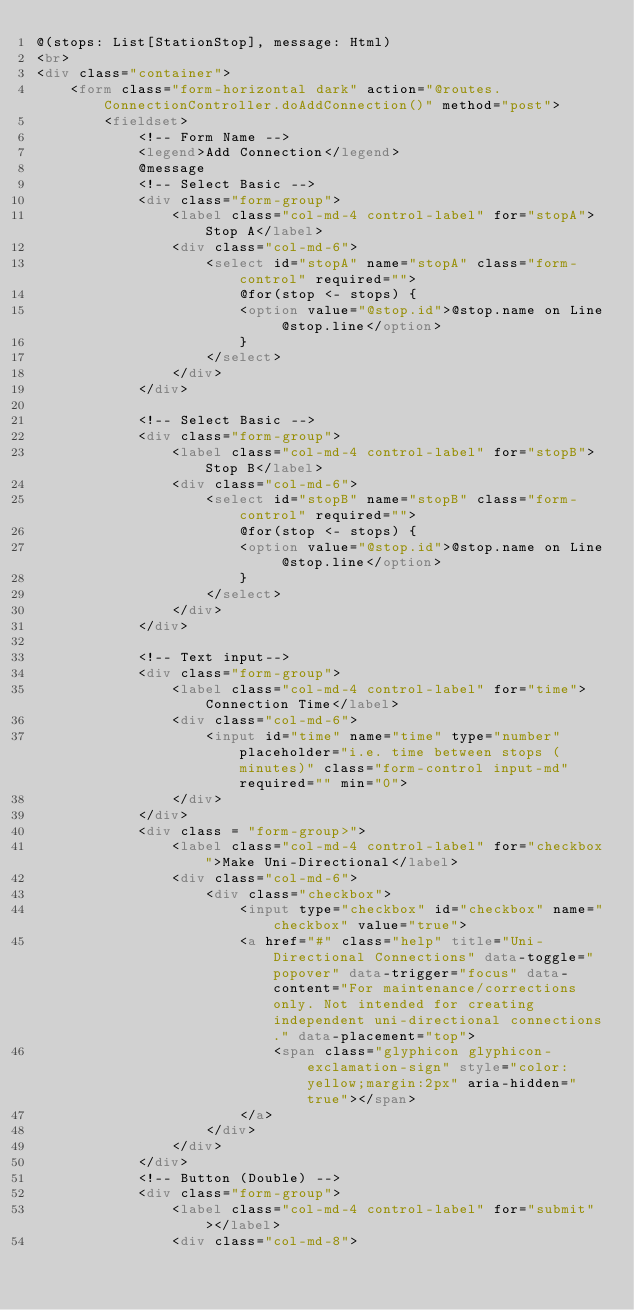Convert code to text. <code><loc_0><loc_0><loc_500><loc_500><_HTML_>@(stops: List[StationStop], message: Html)
<br>
<div class="container">
    <form class="form-horizontal dark" action="@routes.ConnectionController.doAddConnection()" method="post">
        <fieldset>
            <!-- Form Name -->
            <legend>Add Connection</legend>
            @message
            <!-- Select Basic -->
            <div class="form-group">
                <label class="col-md-4 control-label" for="stopA">Stop A</label>
                <div class="col-md-6">
                    <select id="stopA" name="stopA" class="form-control" required="">
                        @for(stop <- stops) {
                        <option value="@stop.id">@stop.name on Line @stop.line</option>
                        }
                    </select>
                </div>
            </div>

            <!-- Select Basic -->
            <div class="form-group">
                <label class="col-md-4 control-label" for="stopB">Stop B</label>
                <div class="col-md-6">
                    <select id="stopB" name="stopB" class="form-control" required="">
                        @for(stop <- stops) {
                        <option value="@stop.id">@stop.name on Line @stop.line</option>
                        }
                    </select>
                </div>
            </div>

            <!-- Text input-->
            <div class="form-group">
                <label class="col-md-4 control-label" for="time">Connection Time</label>
                <div class="col-md-6">
                    <input id="time" name="time" type="number" placeholder="i.e. time between stops (minutes)" class="form-control input-md" required="" min="0">
                </div>
            </div>
            <div class = "form-group>">
                <label class="col-md-4 control-label" for="checkbox">Make Uni-Directional</label>
                <div class="col-md-6">
                    <div class="checkbox">
                        <input type="checkbox" id="checkbox" name="checkbox" value="true">
                        <a href="#" class="help" title="Uni-Directional Connections" data-toggle="popover" data-trigger="focus" data-content="For maintenance/corrections only. Not intended for creating independent uni-directional connections." data-placement="top">
                            <span class="glyphicon glyphicon-exclamation-sign" style="color:yellow;margin:2px" aria-hidden="true"></span>
                        </a>
                    </div>
                </div>
            </div>
            <!-- Button (Double) -->
            <div class="form-group">
                <label class="col-md-4 control-label" for="submit"></label>
                <div class="col-md-8">
</code> 